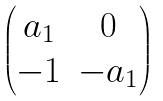<formula> <loc_0><loc_0><loc_500><loc_500>\begin{pmatrix} a _ { 1 } & 0 \\ - 1 & - a _ { 1 } \end{pmatrix}</formula> 